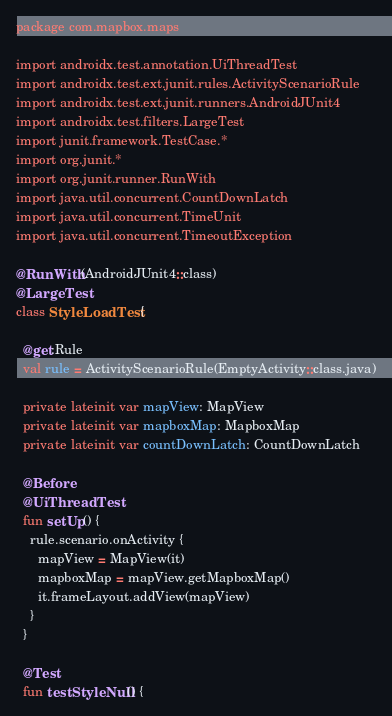<code> <loc_0><loc_0><loc_500><loc_500><_Kotlin_>package com.mapbox.maps

import androidx.test.annotation.UiThreadTest
import androidx.test.ext.junit.rules.ActivityScenarioRule
import androidx.test.ext.junit.runners.AndroidJUnit4
import androidx.test.filters.LargeTest
import junit.framework.TestCase.*
import org.junit.*
import org.junit.runner.RunWith
import java.util.concurrent.CountDownLatch
import java.util.concurrent.TimeUnit
import java.util.concurrent.TimeoutException

@RunWith(AndroidJUnit4::class)
@LargeTest
class StyleLoadTest {

  @get:Rule
  val rule = ActivityScenarioRule(EmptyActivity::class.java)

  private lateinit var mapView: MapView
  private lateinit var mapboxMap: MapboxMap
  private lateinit var countDownLatch: CountDownLatch

  @Before
  @UiThreadTest
  fun setUp() {
    rule.scenario.onActivity {
      mapView = MapView(it)
      mapboxMap = mapView.getMapboxMap()
      it.frameLayout.addView(mapView)
    }
  }

  @Test
  fun testStyleNull() {</code> 